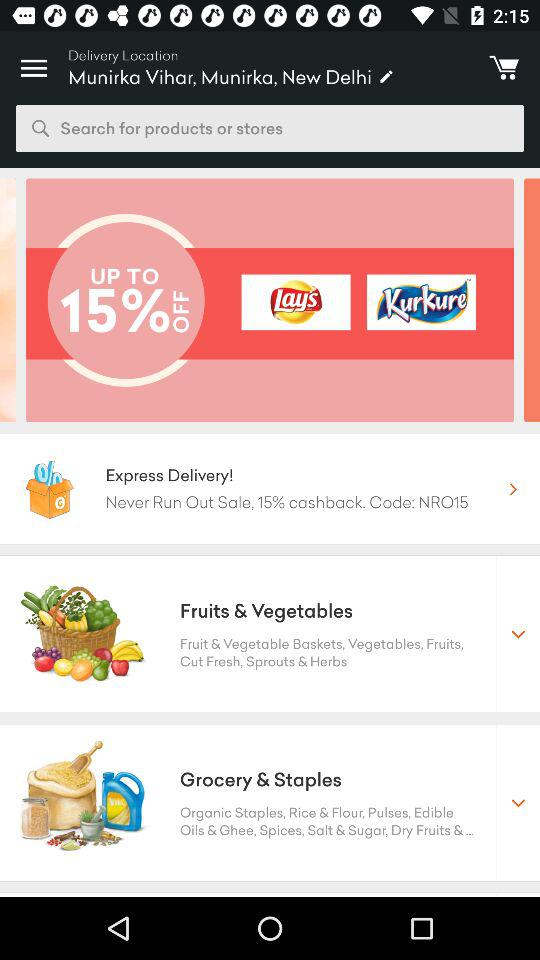What is the delivery location? The delivery location is "Munirka Vihar, Munirka, New Delhi". 